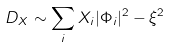Convert formula to latex. <formula><loc_0><loc_0><loc_500><loc_500>D _ { X } \sim \sum _ { i } X _ { i } | \Phi _ { i } | ^ { 2 } - \xi ^ { 2 }</formula> 